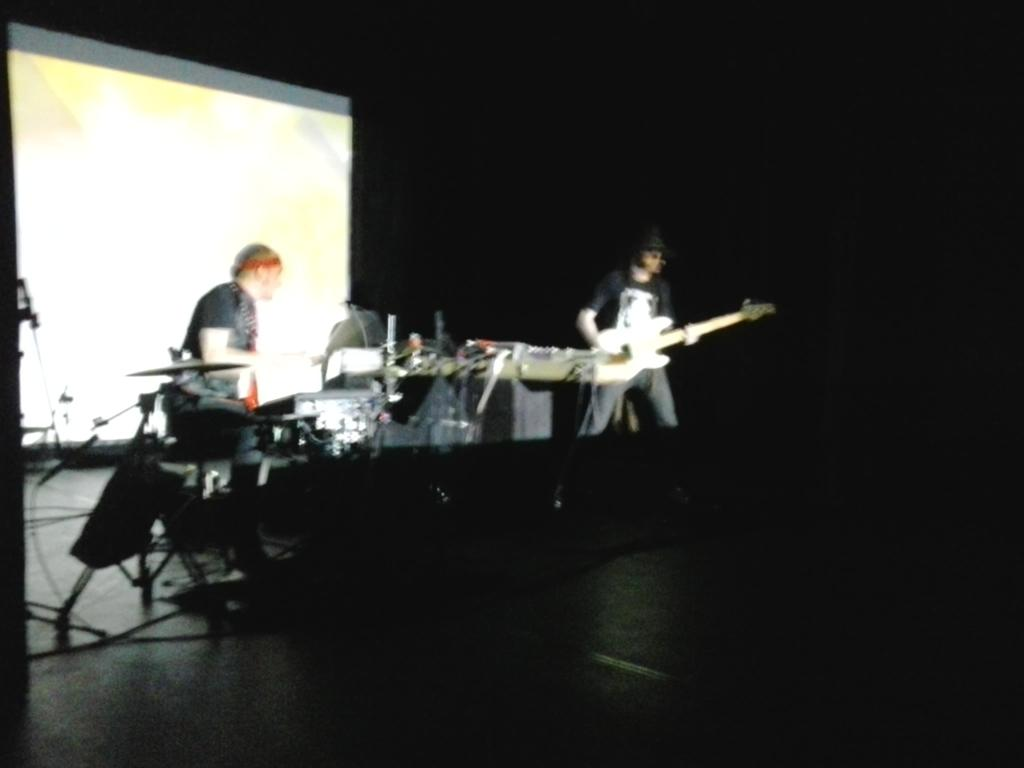What is the person sitting on in the image? There is a person sitting on a chair in the image. What is the person doing while sitting on the chair? The person is playing a musical instrument. What is the standing person holding in the image? The standing person is holding a guitar. What can be seen in the background of the image? There is a screen in the background. What level of fear does the person sitting on the chair exhibit in the image? There is no indication of fear in the image; the person is simply sitting on a chair and playing a musical instrument. 